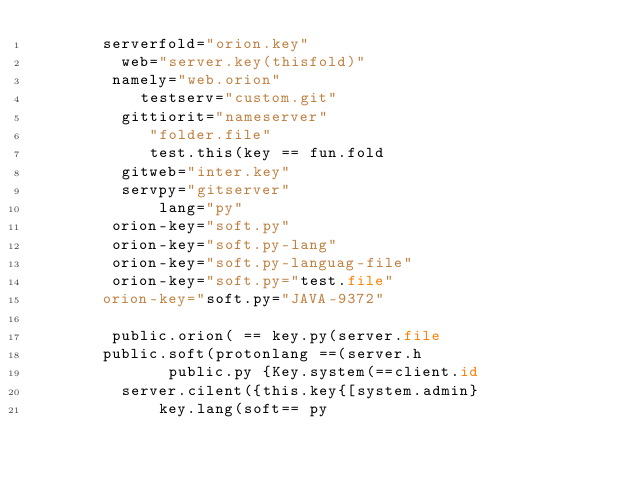Convert code to text. <code><loc_0><loc_0><loc_500><loc_500><_Python_>       serverfold="orion.key"
         web="server.key(thisfold)"
        namely="web.orion"
           testserv="custom.git"
         gittiorit="nameserver"
            "folder.file"
            test.this(key == fun.fold
         gitweb="inter.key"
         servpy="gitserver"
             lang="py"
        orion-key="soft.py"
        orion-key="soft.py-lang"
        orion-key="soft.py-languag-file"
        orion-key="soft.py="test.file"
       orion-key="soft.py="JAVA-9372"
          
        public.orion( == key.py(server.file
       public.soft(protonlang ==(server.h
              public.py {Key.system(==client.id
         server.cilent({this.key{[system.admin}
             key.lang(soft== py

    

 
       

 
</code> 